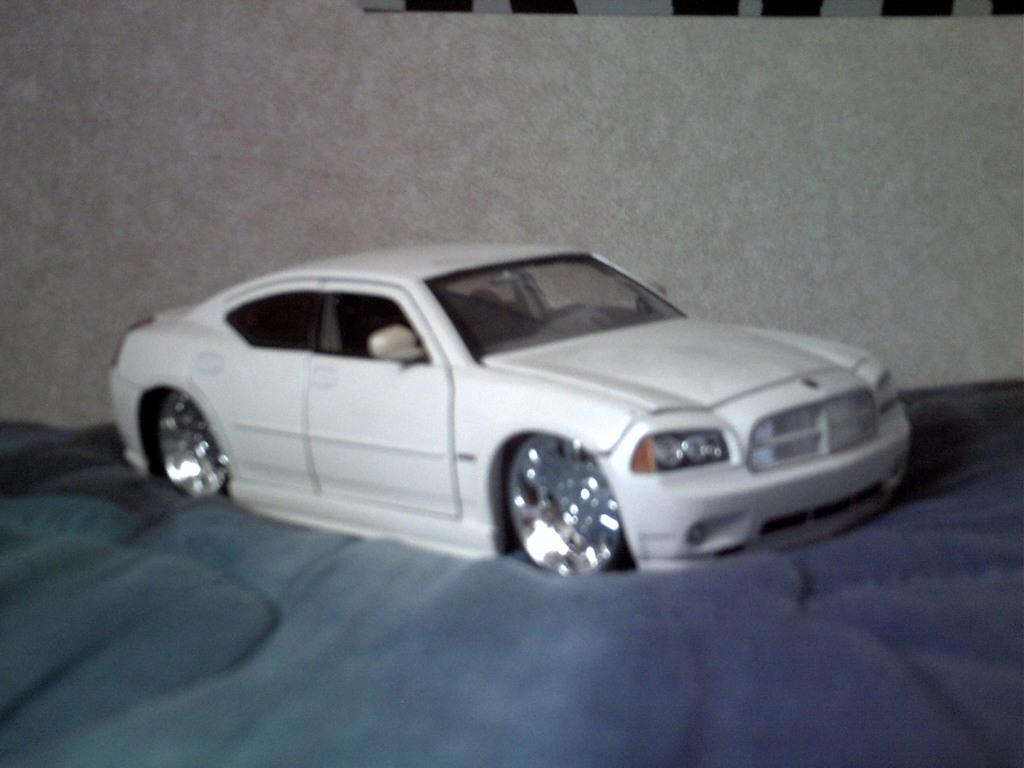What type of vehicle is in the image? There is a white car in the image. What can be seen in the background of the image? There is a wall in the background of the image. What type of brush is being used by the slave in the image? There is no brush or slave present in the image; it only features a white car and a wall in the background. 